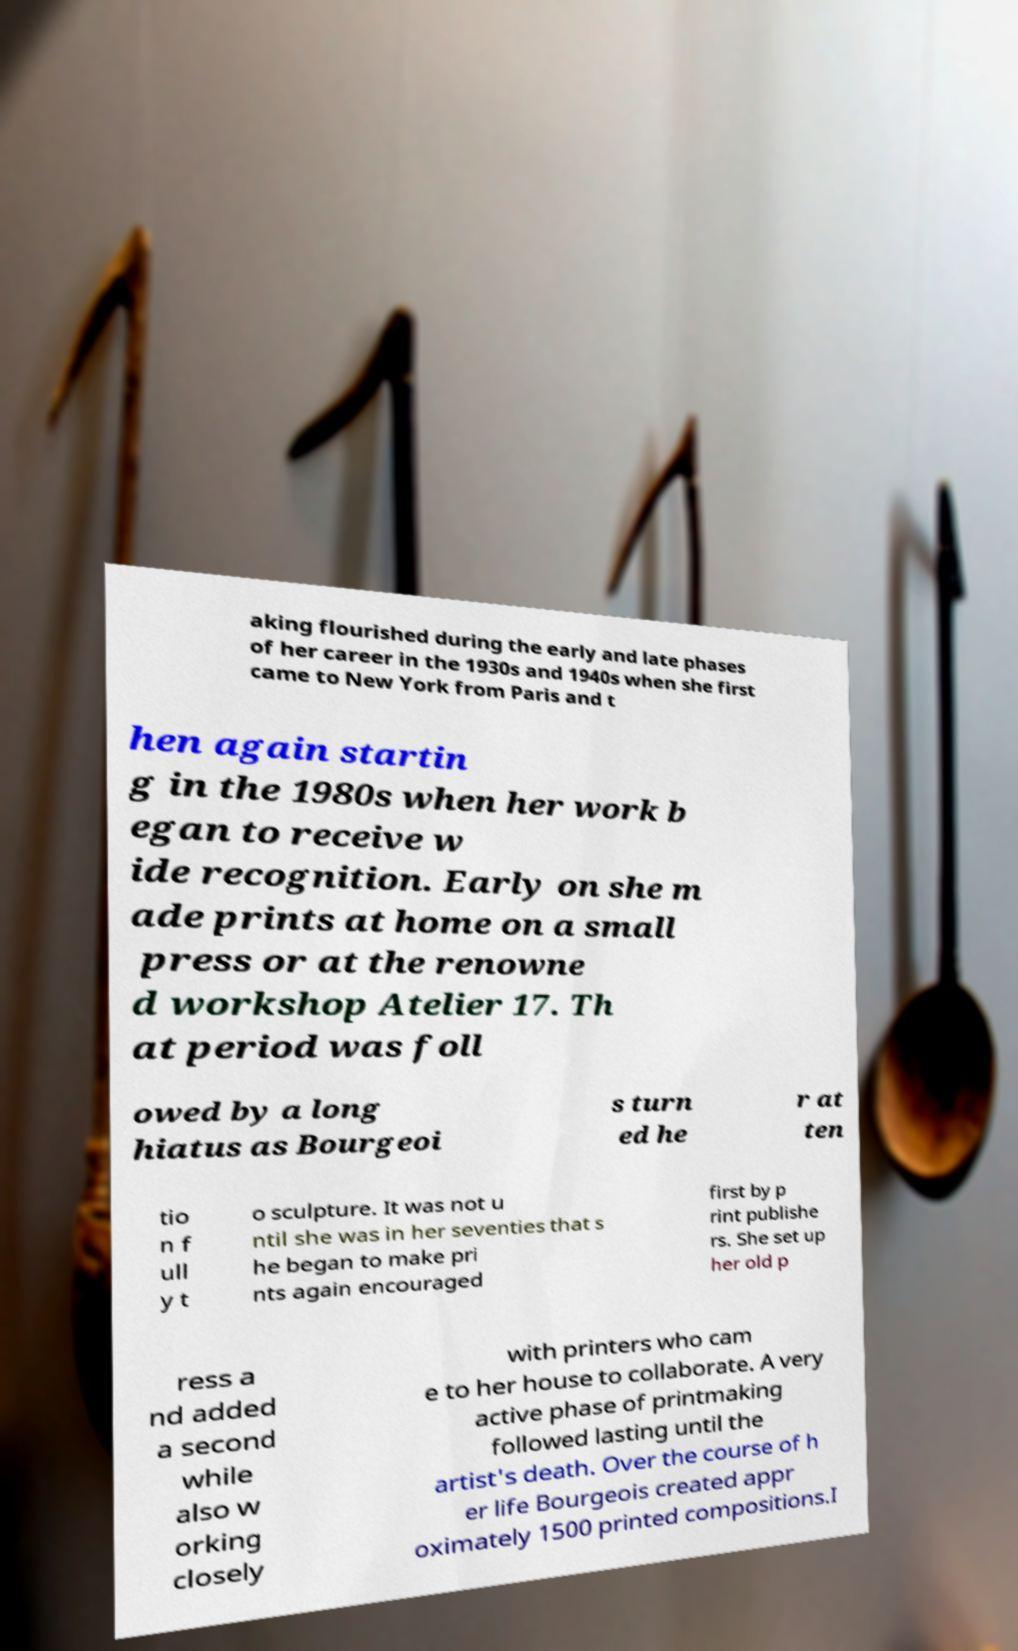There's text embedded in this image that I need extracted. Can you transcribe it verbatim? aking flourished during the early and late phases of her career in the 1930s and 1940s when she first came to New York from Paris and t hen again startin g in the 1980s when her work b egan to receive w ide recognition. Early on she m ade prints at home on a small press or at the renowne d workshop Atelier 17. Th at period was foll owed by a long hiatus as Bourgeoi s turn ed he r at ten tio n f ull y t o sculpture. It was not u ntil she was in her seventies that s he began to make pri nts again encouraged first by p rint publishe rs. She set up her old p ress a nd added a second while also w orking closely with printers who cam e to her house to collaborate. A very active phase of printmaking followed lasting until the artist's death. Over the course of h er life Bourgeois created appr oximately 1500 printed compositions.I 